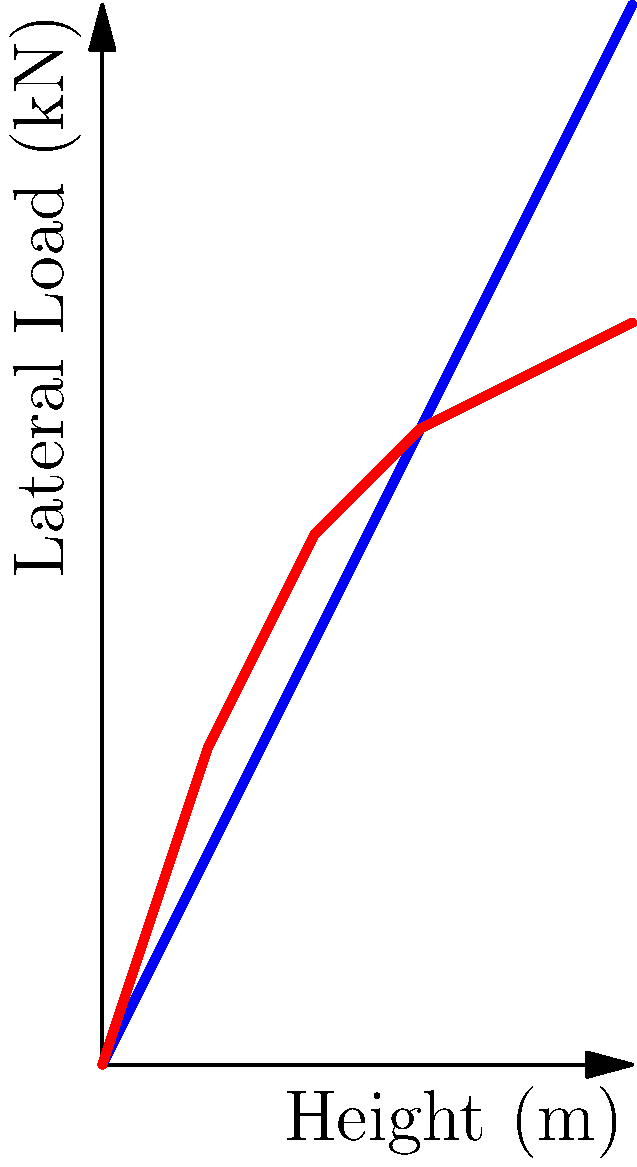As a family business owner expanding into multi-story building construction, you're reviewing structural stability analysis. The graph shows wind and seismic load distributions for a 50-meter tall building. At what height does the seismic load become less critical than the wind load for structural design considerations? To determine the height at which the seismic load becomes less critical than the wind load, we need to analyze the graph step-by-step:

1. Observe that both load distributions start at (0,0) and increase with height.
2. The seismic load (red line) initially increases more rapidly than the wind load (blue line).
3. As we move up the height:
   - At 10m: Seismic load ≈ 30 kN, Wind load ≈ 20 kN
   - At 20m: Seismic load ≈ 50 kN, Wind load ≈ 40 kN
   - At 30m: Seismic load ≈ 60 kN, Wind load ≈ 60 kN
4. Notice that around 30m, the two lines intersect.
5. Above 30m:
   - At 40m: Seismic load ≈ 65 kN, Wind load ≈ 80 kN
   - At 50m: Seismic load ≈ 70 kN, Wind load = 100 kN

The point of intersection, approximately 30 meters, is where the seismic load becomes equal to the wind load. Above this height, the wind load becomes more critical for structural design considerations.

Therefore, the seismic load becomes less critical than the wind load at approximately 30 meters height.
Answer: 30 meters 